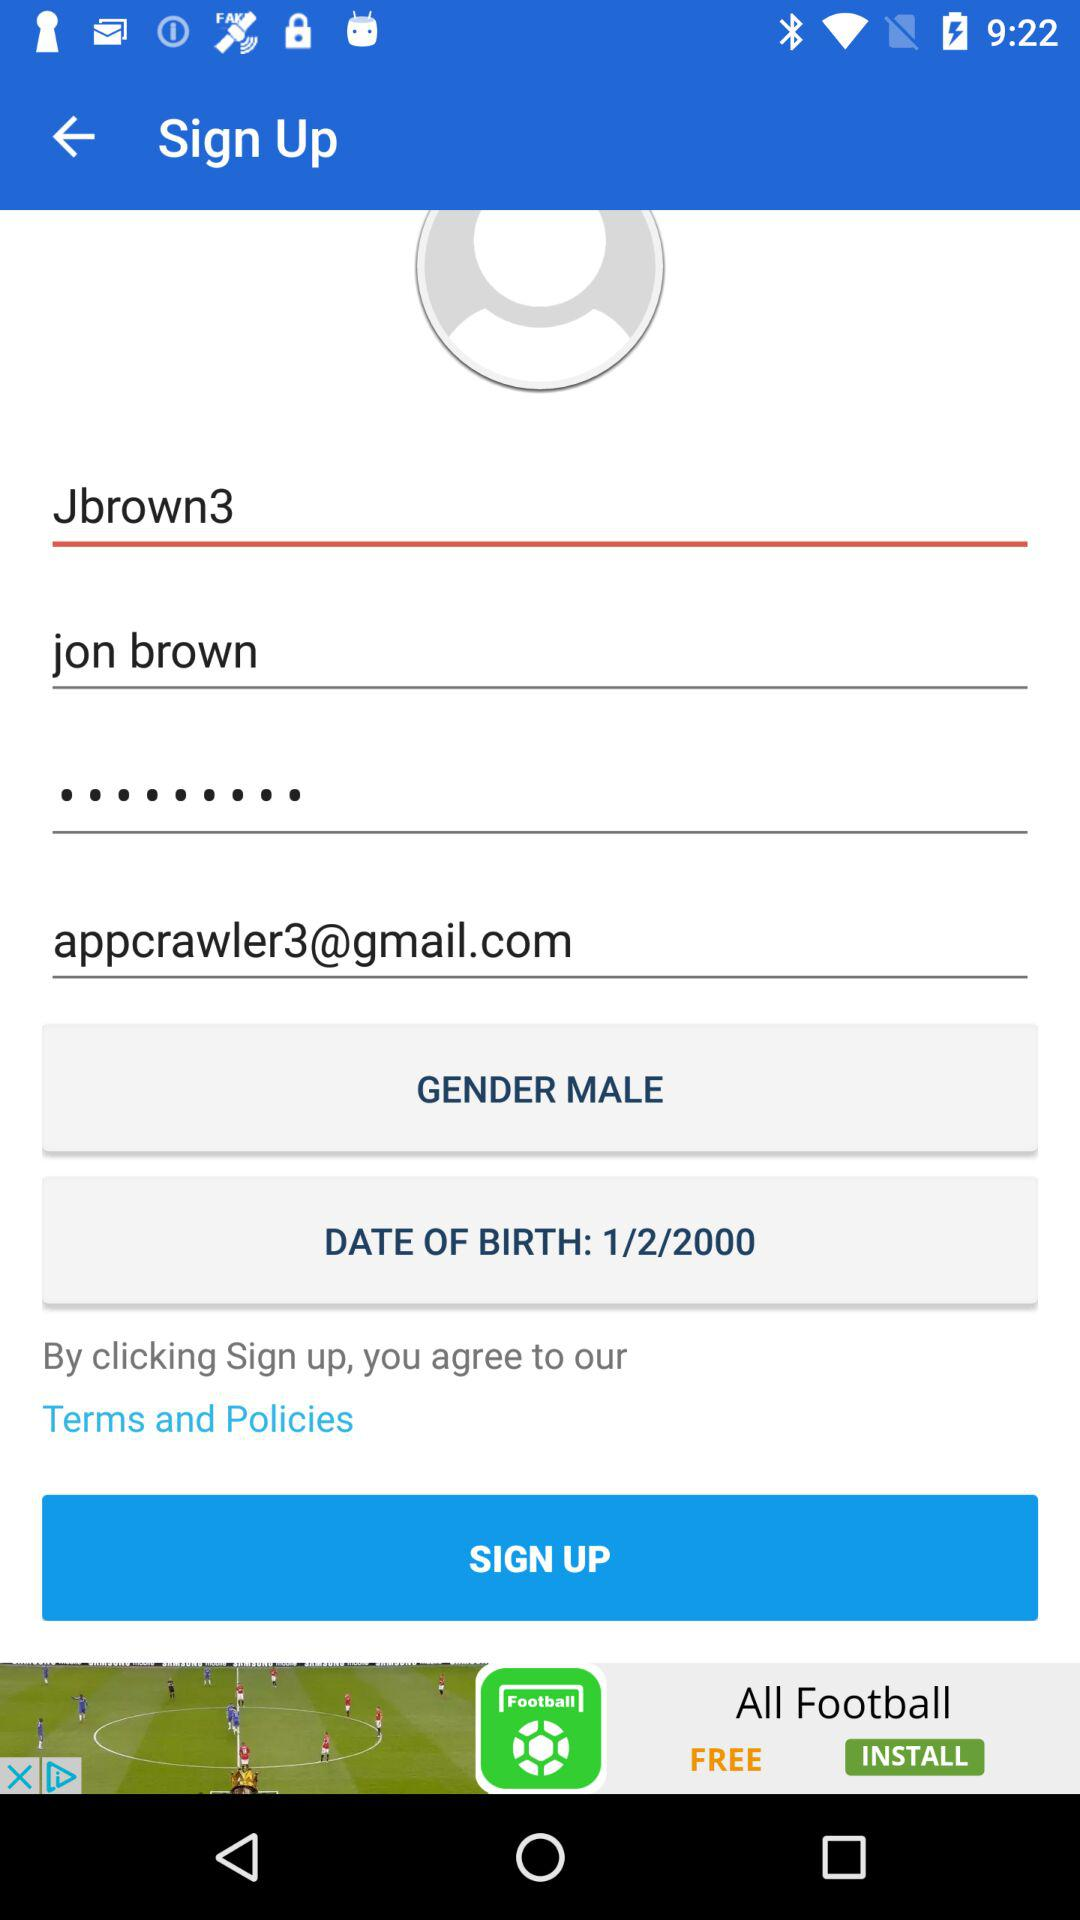What is the mentioned gender? The gender is male. 